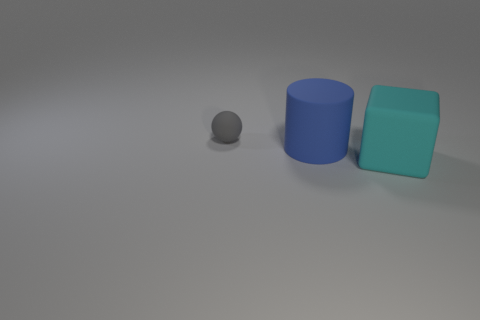Is the large object that is to the left of the big cyan rubber thing made of the same material as the big thing that is in front of the large rubber cylinder?
Make the answer very short. Yes. What number of gray things are either tiny rubber blocks or rubber spheres?
Offer a very short reply. 1. The cyan rubber block has what size?
Offer a terse response. Large. Are there more big cyan blocks in front of the block than small matte balls?
Ensure brevity in your answer.  No. What number of matte blocks are in front of the small gray sphere?
Provide a short and direct response. 1. Is there a cyan metal thing of the same size as the ball?
Give a very brief answer. No. There is a rubber object behind the blue cylinder; does it have the same size as the matte object on the right side of the big rubber cylinder?
Make the answer very short. No. Are there any yellow metallic objects that have the same shape as the small rubber object?
Offer a terse response. No. Is the number of large blue rubber cylinders behind the blue matte object the same as the number of cyan metallic balls?
Make the answer very short. Yes. There is a gray matte ball; is it the same size as the matte object that is to the right of the blue rubber object?
Make the answer very short. No. 